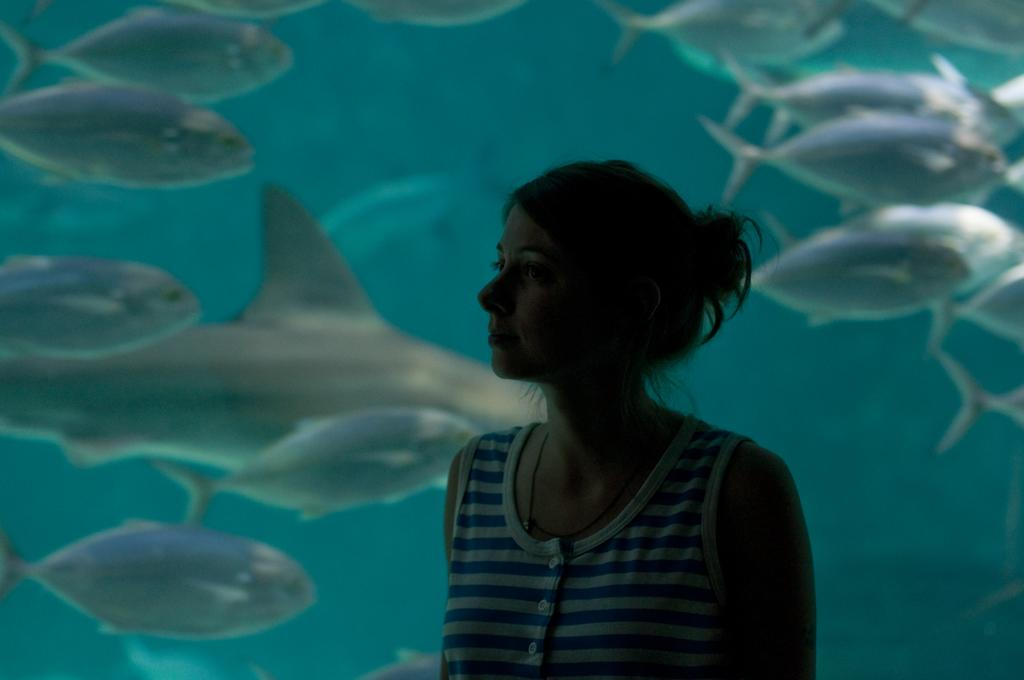Who is present in the image? There is a woman in the image. What can be seen in the background of the image? There is a large fish tank in the image. What type of animals are visible in the fish tank? There are aquatic animals visible in the fish tank. What letter is the woman holding in the image? There is no letter present in the image; the woman is not holding anything. 